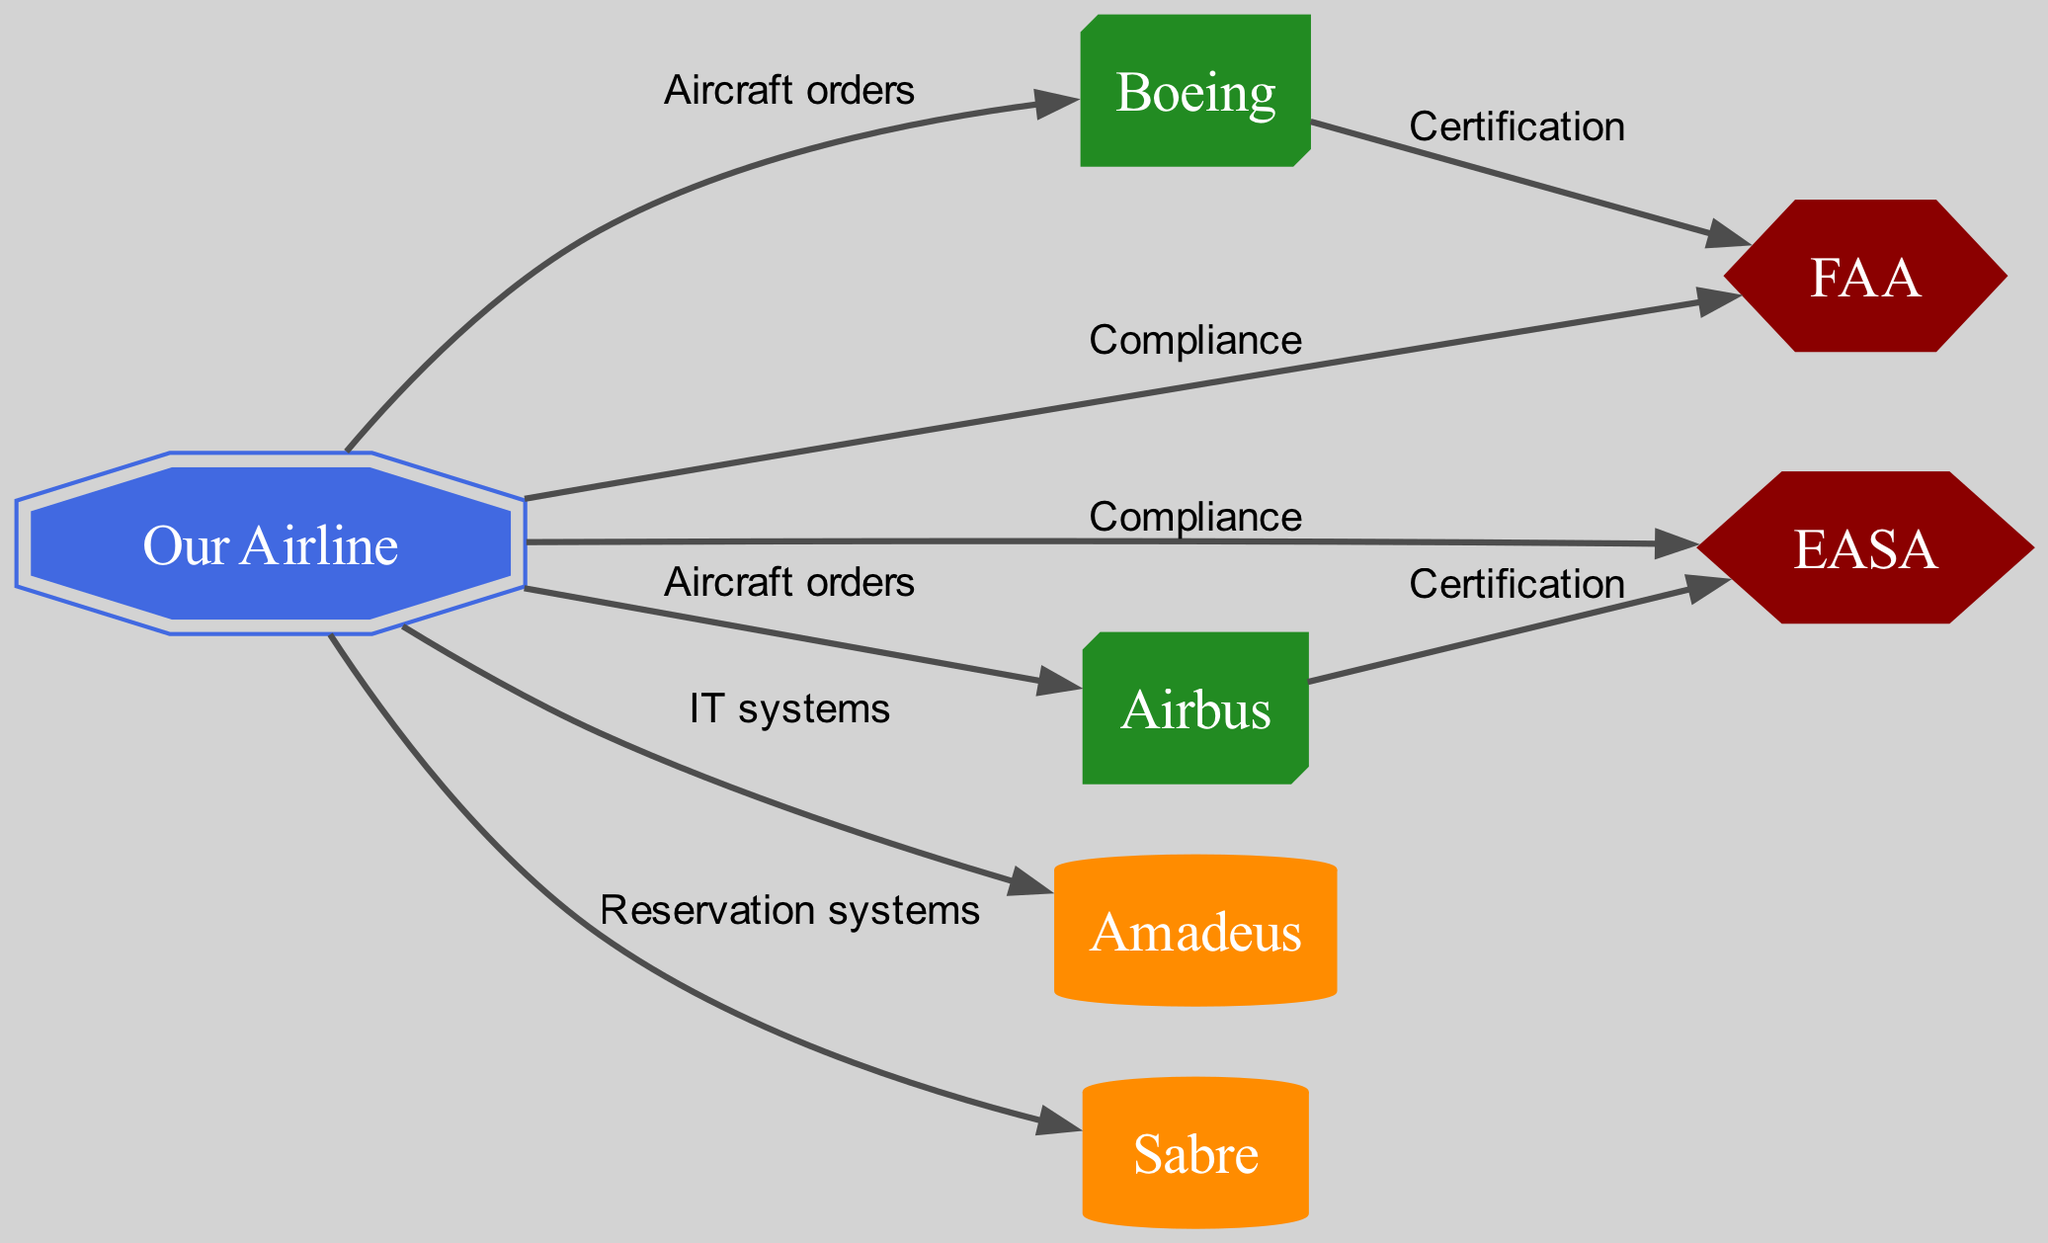What is the central node of the diagram? The central node is "Our Airline" which represents the main focus of the stakeholder map. It is depicted as a double octagon shape and connects to multiple other nodes.
Answer: Our Airline How many manufacturers are represented in the diagram? There are two manufacturers illustrated in the diagram: Boeing and Airbus. They are both categorized under the type "manufacturer" and represented with specific shapes.
Answer: 2 What type of edge connects the airline to the FAA? The edge connecting "Our Airline" to "FAA" is labeled "Compliance," indicating a relationship concerning adherence to regulation.
Answer: Compliance Which technology provider is associated with reservation systems? The technology provider linked with reservation systems is "Sabre." This connection is indicated by a direct edge from "Our Airline" to "Sabre" labeled with that relationship.
Answer: Sabre How many edges connect the airline to manufacturers? The airline connects to two manufacturers: Boeing and Airbus, resulting in a total of two edges dedicated to aircraft orders.
Answer: 2 Which regulator certifies Boeing? The regulator that certifies Boeing is the FAA, as shown by the edge labeled "Certification" that stems from Boeing to FAA.
Answer: FAA What shape represents the type of technology provider in the diagram? Technology providers in the diagram are represented by a cylinder shape, as denoted in the node styling for both "Amadeus" and "Sabre."
Answer: Cylinder Which node has a direct relationship with both the airline and European regulators? The airline has direct edges to EASA (European regulator) and compliance-related edges to both FAA and EASA, establishing its interactions with these regulators.
Answer: EASA What is the relationship type between Airbus and EASA? The relationship type between Airbus and EASA is labeled "Certification," demonstrating the certification process that Airbus must engage with the European regulator.
Answer: Certification 